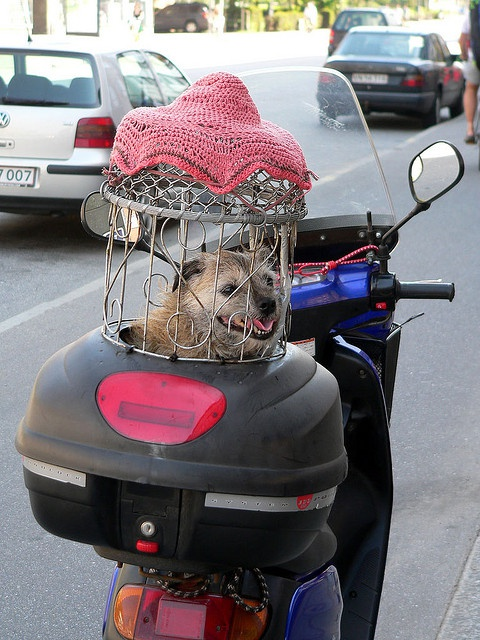Describe the objects in this image and their specific colors. I can see motorcycle in white, black, gray, darkgray, and lightgray tones, car in white, darkgray, black, and gray tones, dog in white, gray, darkgray, and black tones, car in white, black, gray, and darkgray tones, and people in white, gray, darkgray, and lavender tones in this image. 